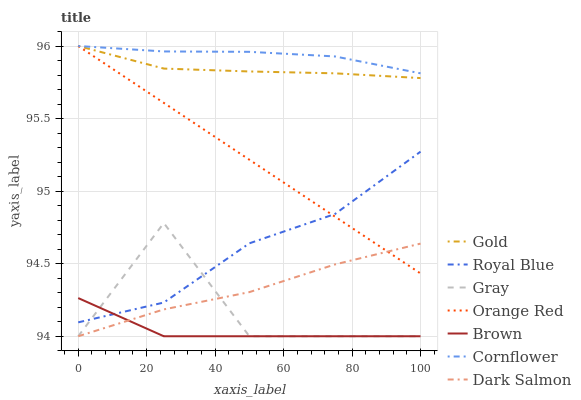Does Brown have the minimum area under the curve?
Answer yes or no. Yes. Does Cornflower have the maximum area under the curve?
Answer yes or no. Yes. Does Gold have the minimum area under the curve?
Answer yes or no. No. Does Gold have the maximum area under the curve?
Answer yes or no. No. Is Orange Red the smoothest?
Answer yes or no. Yes. Is Gray the roughest?
Answer yes or no. Yes. Is Gold the smoothest?
Answer yes or no. No. Is Gold the roughest?
Answer yes or no. No. Does Brown have the lowest value?
Answer yes or no. Yes. Does Gold have the lowest value?
Answer yes or no. No. Does Orange Red have the highest value?
Answer yes or no. Yes. Does Dark Salmon have the highest value?
Answer yes or no. No. Is Dark Salmon less than Gold?
Answer yes or no. Yes. Is Cornflower greater than Brown?
Answer yes or no. Yes. Does Dark Salmon intersect Orange Red?
Answer yes or no. Yes. Is Dark Salmon less than Orange Red?
Answer yes or no. No. Is Dark Salmon greater than Orange Red?
Answer yes or no. No. Does Dark Salmon intersect Gold?
Answer yes or no. No. 